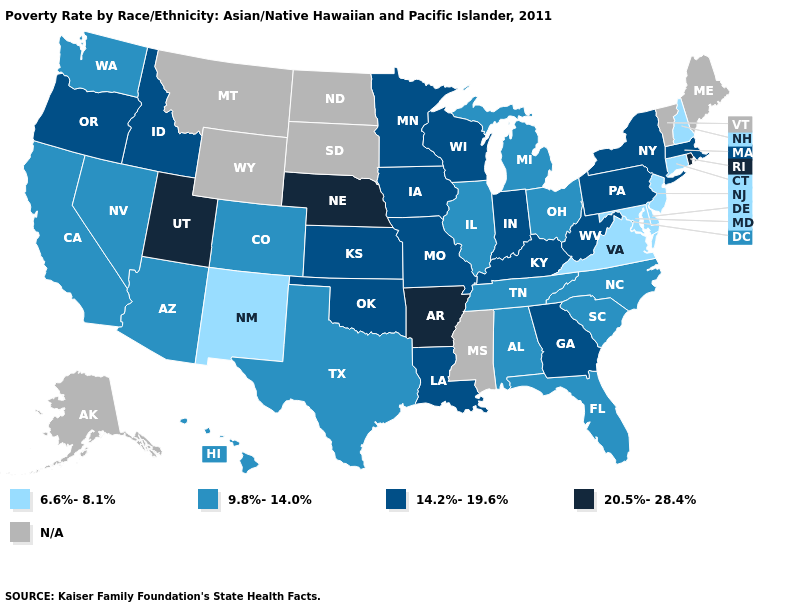Is the legend a continuous bar?
Answer briefly. No. Is the legend a continuous bar?
Answer briefly. No. Does Minnesota have the highest value in the MidWest?
Concise answer only. No. What is the highest value in the USA?
Quick response, please. 20.5%-28.4%. Does Delaware have the highest value in the South?
Write a very short answer. No. Name the states that have a value in the range 9.8%-14.0%?
Concise answer only. Alabama, Arizona, California, Colorado, Florida, Hawaii, Illinois, Michigan, Nevada, North Carolina, Ohio, South Carolina, Tennessee, Texas, Washington. What is the lowest value in the Northeast?
Quick response, please. 6.6%-8.1%. Among the states that border Missouri , which have the lowest value?
Keep it brief. Illinois, Tennessee. Name the states that have a value in the range 9.8%-14.0%?
Answer briefly. Alabama, Arizona, California, Colorado, Florida, Hawaii, Illinois, Michigan, Nevada, North Carolina, Ohio, South Carolina, Tennessee, Texas, Washington. Name the states that have a value in the range N/A?
Quick response, please. Alaska, Maine, Mississippi, Montana, North Dakota, South Dakota, Vermont, Wyoming. Is the legend a continuous bar?
Concise answer only. No. What is the value of California?
Concise answer only. 9.8%-14.0%. Name the states that have a value in the range 20.5%-28.4%?
Short answer required. Arkansas, Nebraska, Rhode Island, Utah. Name the states that have a value in the range 20.5%-28.4%?
Answer briefly. Arkansas, Nebraska, Rhode Island, Utah. 